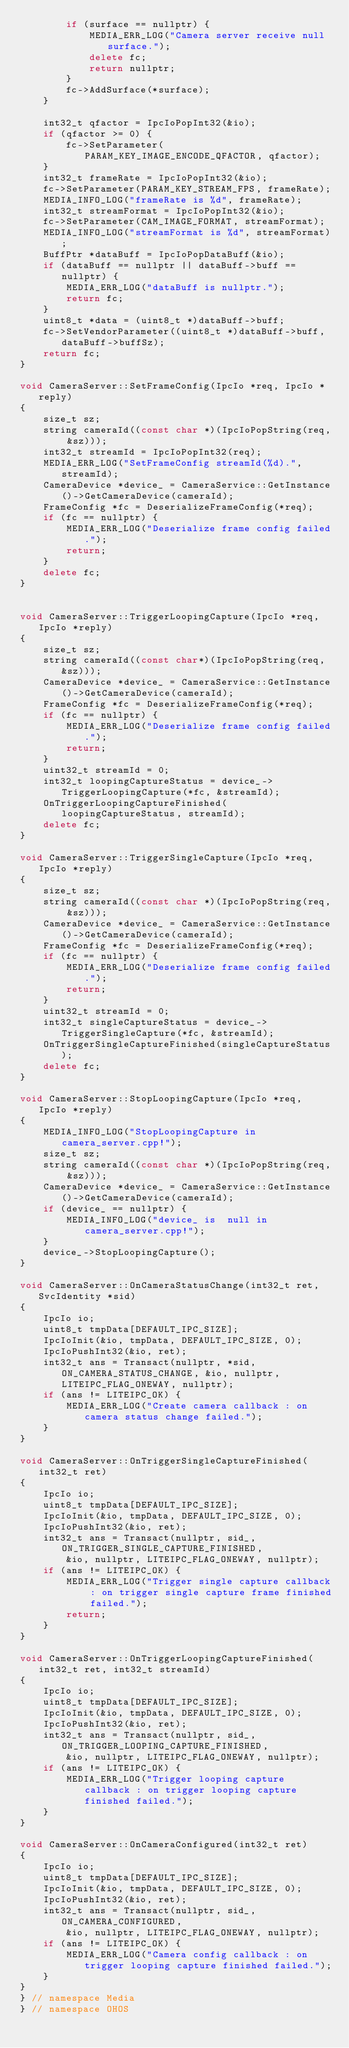Convert code to text. <code><loc_0><loc_0><loc_500><loc_500><_C++_>        if (surface == nullptr) {
            MEDIA_ERR_LOG("Camera server receive null surface.");
            delete fc;
            return nullptr;
        }
        fc->AddSurface(*surface);
    }

    int32_t qfactor = IpcIoPopInt32(&io);
    if (qfactor >= 0) {
        fc->SetParameter(PARAM_KEY_IMAGE_ENCODE_QFACTOR, qfactor);
    }
    int32_t frameRate = IpcIoPopInt32(&io);
    fc->SetParameter(PARAM_KEY_STREAM_FPS, frameRate);
    MEDIA_INFO_LOG("frameRate is %d", frameRate);
    int32_t streamFormat = IpcIoPopInt32(&io);
    fc->SetParameter(CAM_IMAGE_FORMAT, streamFormat);
    MEDIA_INFO_LOG("streamFormat is %d", streamFormat);
    BuffPtr *dataBuff = IpcIoPopDataBuff(&io);
    if (dataBuff == nullptr || dataBuff->buff == nullptr) {
        MEDIA_ERR_LOG("dataBuff is nullptr.");
        return fc;
    }
    uint8_t *data = (uint8_t *)dataBuff->buff;
    fc->SetVendorParameter((uint8_t *)dataBuff->buff, dataBuff->buffSz);
    return fc;
}

void CameraServer::SetFrameConfig(IpcIo *req, IpcIo *reply)
{
    size_t sz;
    string cameraId((const char *)(IpcIoPopString(req, &sz)));
    int32_t streamId = IpcIoPopInt32(req);
    MEDIA_ERR_LOG("SetFrameConfig streamId(%d).", streamId);
    CameraDevice *device_ = CameraService::GetInstance()->GetCameraDevice(cameraId);
    FrameConfig *fc = DeserializeFrameConfig(*req);
    if (fc == nullptr) {
        MEDIA_ERR_LOG("Deserialize frame config failed.");
        return;
    }
    delete fc;
}


void CameraServer::TriggerLoopingCapture(IpcIo *req, IpcIo *reply)
{
    size_t sz;
    string cameraId((const char*)(IpcIoPopString(req, &sz)));
    CameraDevice *device_ = CameraService::GetInstance()->GetCameraDevice(cameraId);
    FrameConfig *fc = DeserializeFrameConfig(*req);
    if (fc == nullptr) {
        MEDIA_ERR_LOG("Deserialize frame config failed.");
        return;
    }
    uint32_t streamId = 0;
    int32_t loopingCaptureStatus = device_->TriggerLoopingCapture(*fc, &streamId);
    OnTriggerLoopingCaptureFinished(loopingCaptureStatus, streamId);
    delete fc;
}

void CameraServer::TriggerSingleCapture(IpcIo *req, IpcIo *reply)
{
    size_t sz;
    string cameraId((const char *)(IpcIoPopString(req, &sz)));
    CameraDevice *device_ = CameraService::GetInstance()->GetCameraDevice(cameraId);
    FrameConfig *fc = DeserializeFrameConfig(*req);
    if (fc == nullptr) {
        MEDIA_ERR_LOG("Deserialize frame config failed.");
        return;
    }
    uint32_t streamId = 0;
    int32_t singleCaptureStatus = device_->TriggerSingleCapture(*fc, &streamId);
    OnTriggerSingleCaptureFinished(singleCaptureStatus);
    delete fc;
}

void CameraServer::StopLoopingCapture(IpcIo *req, IpcIo *reply)
{
    MEDIA_INFO_LOG("StopLoopingCapture in camera_server.cpp!");
    size_t sz;
    string cameraId((const char *)(IpcIoPopString(req, &sz)));
    CameraDevice *device_ = CameraService::GetInstance()->GetCameraDevice(cameraId);
    if (device_ == nullptr) {
        MEDIA_INFO_LOG("device_ is  null in camera_server.cpp!");
    }
    device_->StopLoopingCapture();
}

void CameraServer::OnCameraStatusChange(int32_t ret, SvcIdentity *sid)
{
    IpcIo io;
    uint8_t tmpData[DEFAULT_IPC_SIZE];
    IpcIoInit(&io, tmpData, DEFAULT_IPC_SIZE, 0);
    IpcIoPushInt32(&io, ret);
    int32_t ans = Transact(nullptr, *sid, ON_CAMERA_STATUS_CHANGE, &io, nullptr, LITEIPC_FLAG_ONEWAY, nullptr);
    if (ans != LITEIPC_OK) {
        MEDIA_ERR_LOG("Create camera callback : on camera status change failed.");
    }
}

void CameraServer::OnTriggerSingleCaptureFinished(int32_t ret)
{
    IpcIo io;
    uint8_t tmpData[DEFAULT_IPC_SIZE];
    IpcIoInit(&io, tmpData, DEFAULT_IPC_SIZE, 0);
    IpcIoPushInt32(&io, ret);
    int32_t ans = Transact(nullptr, sid_, ON_TRIGGER_SINGLE_CAPTURE_FINISHED,
        &io, nullptr, LITEIPC_FLAG_ONEWAY, nullptr);
    if (ans != LITEIPC_OK) {
        MEDIA_ERR_LOG("Trigger single capture callback : on trigger single capture frame finished failed.");
        return;
    }
}

void CameraServer::OnTriggerLoopingCaptureFinished(int32_t ret, int32_t streamId)
{
    IpcIo io;
    uint8_t tmpData[DEFAULT_IPC_SIZE];
    IpcIoInit(&io, tmpData, DEFAULT_IPC_SIZE, 0);
    IpcIoPushInt32(&io, ret);
    int32_t ans = Transact(nullptr, sid_, ON_TRIGGER_LOOPING_CAPTURE_FINISHED,
        &io, nullptr, LITEIPC_FLAG_ONEWAY, nullptr);
    if (ans != LITEIPC_OK) {
        MEDIA_ERR_LOG("Trigger looping capture callback : on trigger looping capture finished failed.");
    }
}

void CameraServer::OnCameraConfigured(int32_t ret)
{
    IpcIo io;
    uint8_t tmpData[DEFAULT_IPC_SIZE];
    IpcIoInit(&io, tmpData, DEFAULT_IPC_SIZE, 0);
    IpcIoPushInt32(&io, ret);
    int32_t ans = Transact(nullptr, sid_, ON_CAMERA_CONFIGURED,
        &io, nullptr, LITEIPC_FLAG_ONEWAY, nullptr);
    if (ans != LITEIPC_OK) {
        MEDIA_ERR_LOG("Camera config callback : on trigger looping capture finished failed.");
    }
}
} // namespace Media
} // namespace OHOS</code> 